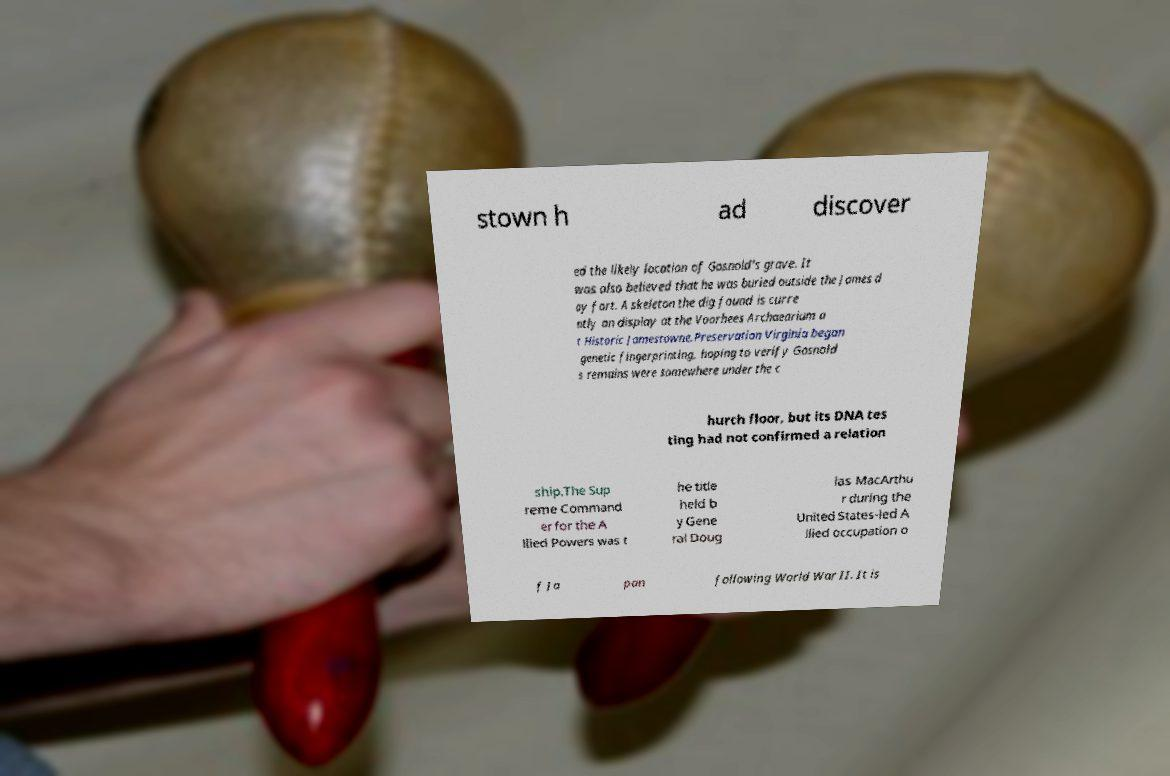Can you read and provide the text displayed in the image?This photo seems to have some interesting text. Can you extract and type it out for me? stown h ad discover ed the likely location of Gosnold's grave. It was also believed that he was buried outside the James d ay fort. A skeleton the dig found is curre ntly on display at the Voorhees Archaearium a t Historic Jamestowne.Preservation Virginia began genetic fingerprinting, hoping to verify Gosnold s remains were somewhere under the c hurch floor, but its DNA tes ting had not confirmed a relation ship.The Sup reme Command er for the A llied Powers was t he title held b y Gene ral Doug las MacArthu r during the United States-led A llied occupation o f Ja pan following World War II. It is 